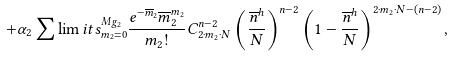<formula> <loc_0><loc_0><loc_500><loc_500>+ \alpha _ { 2 } \sum \lim i t s _ { m _ { 2 } = 0 } ^ { M g _ { 2 } } \frac { e ^ { - \overline { m } _ { 2 } } \overline { m } _ { 2 } ^ { m _ { 2 } } } { m _ { 2 } ! } C ^ { n - 2 } _ { 2 \cdot m _ { 2 } \cdot N } \left ( \frac { \overline { n } ^ { h } } { N } \right ) ^ { n - 2 } \left ( 1 - \frac { \overline { n } ^ { h } } { N } \right ) ^ { 2 \cdot m _ { 2 } \cdot N - ( n - 2 ) } ,</formula> 